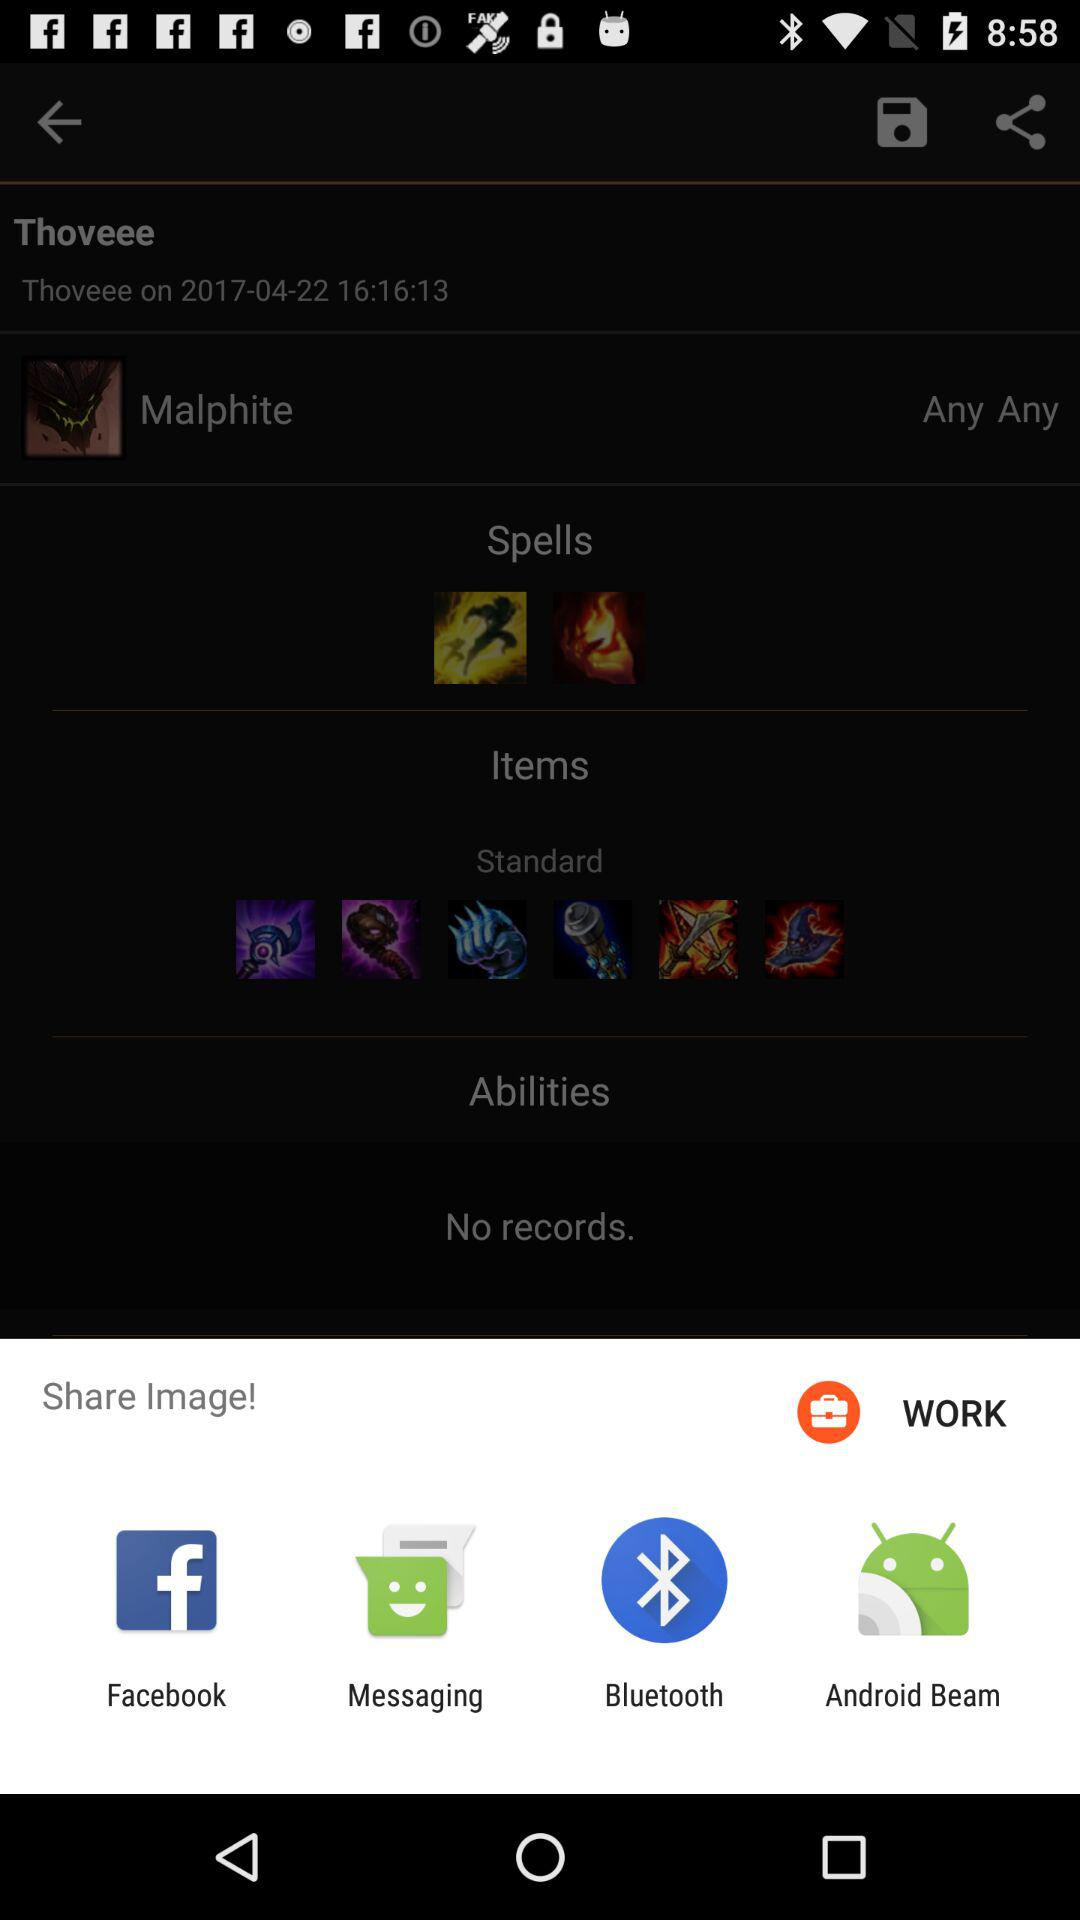What are the sharing options? The sharing options are "Facebook", "Messaging", "Bluetooth" and "Android Beam". 